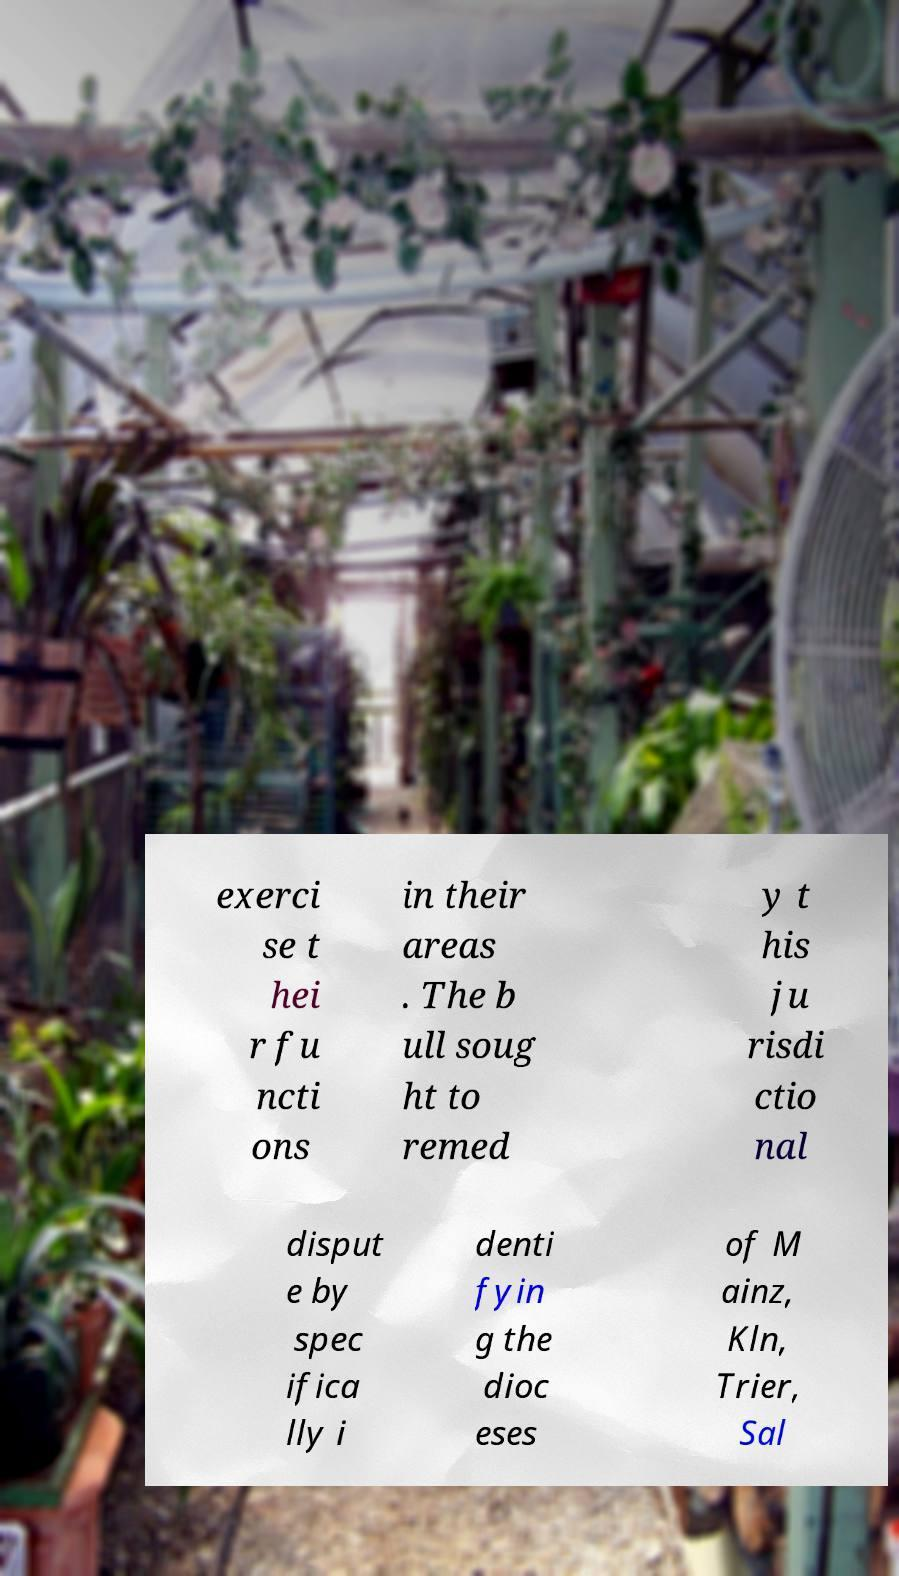Can you read and provide the text displayed in the image?This photo seems to have some interesting text. Can you extract and type it out for me? exerci se t hei r fu ncti ons in their areas . The b ull soug ht to remed y t his ju risdi ctio nal disput e by spec ifica lly i denti fyin g the dioc eses of M ainz, Kln, Trier, Sal 